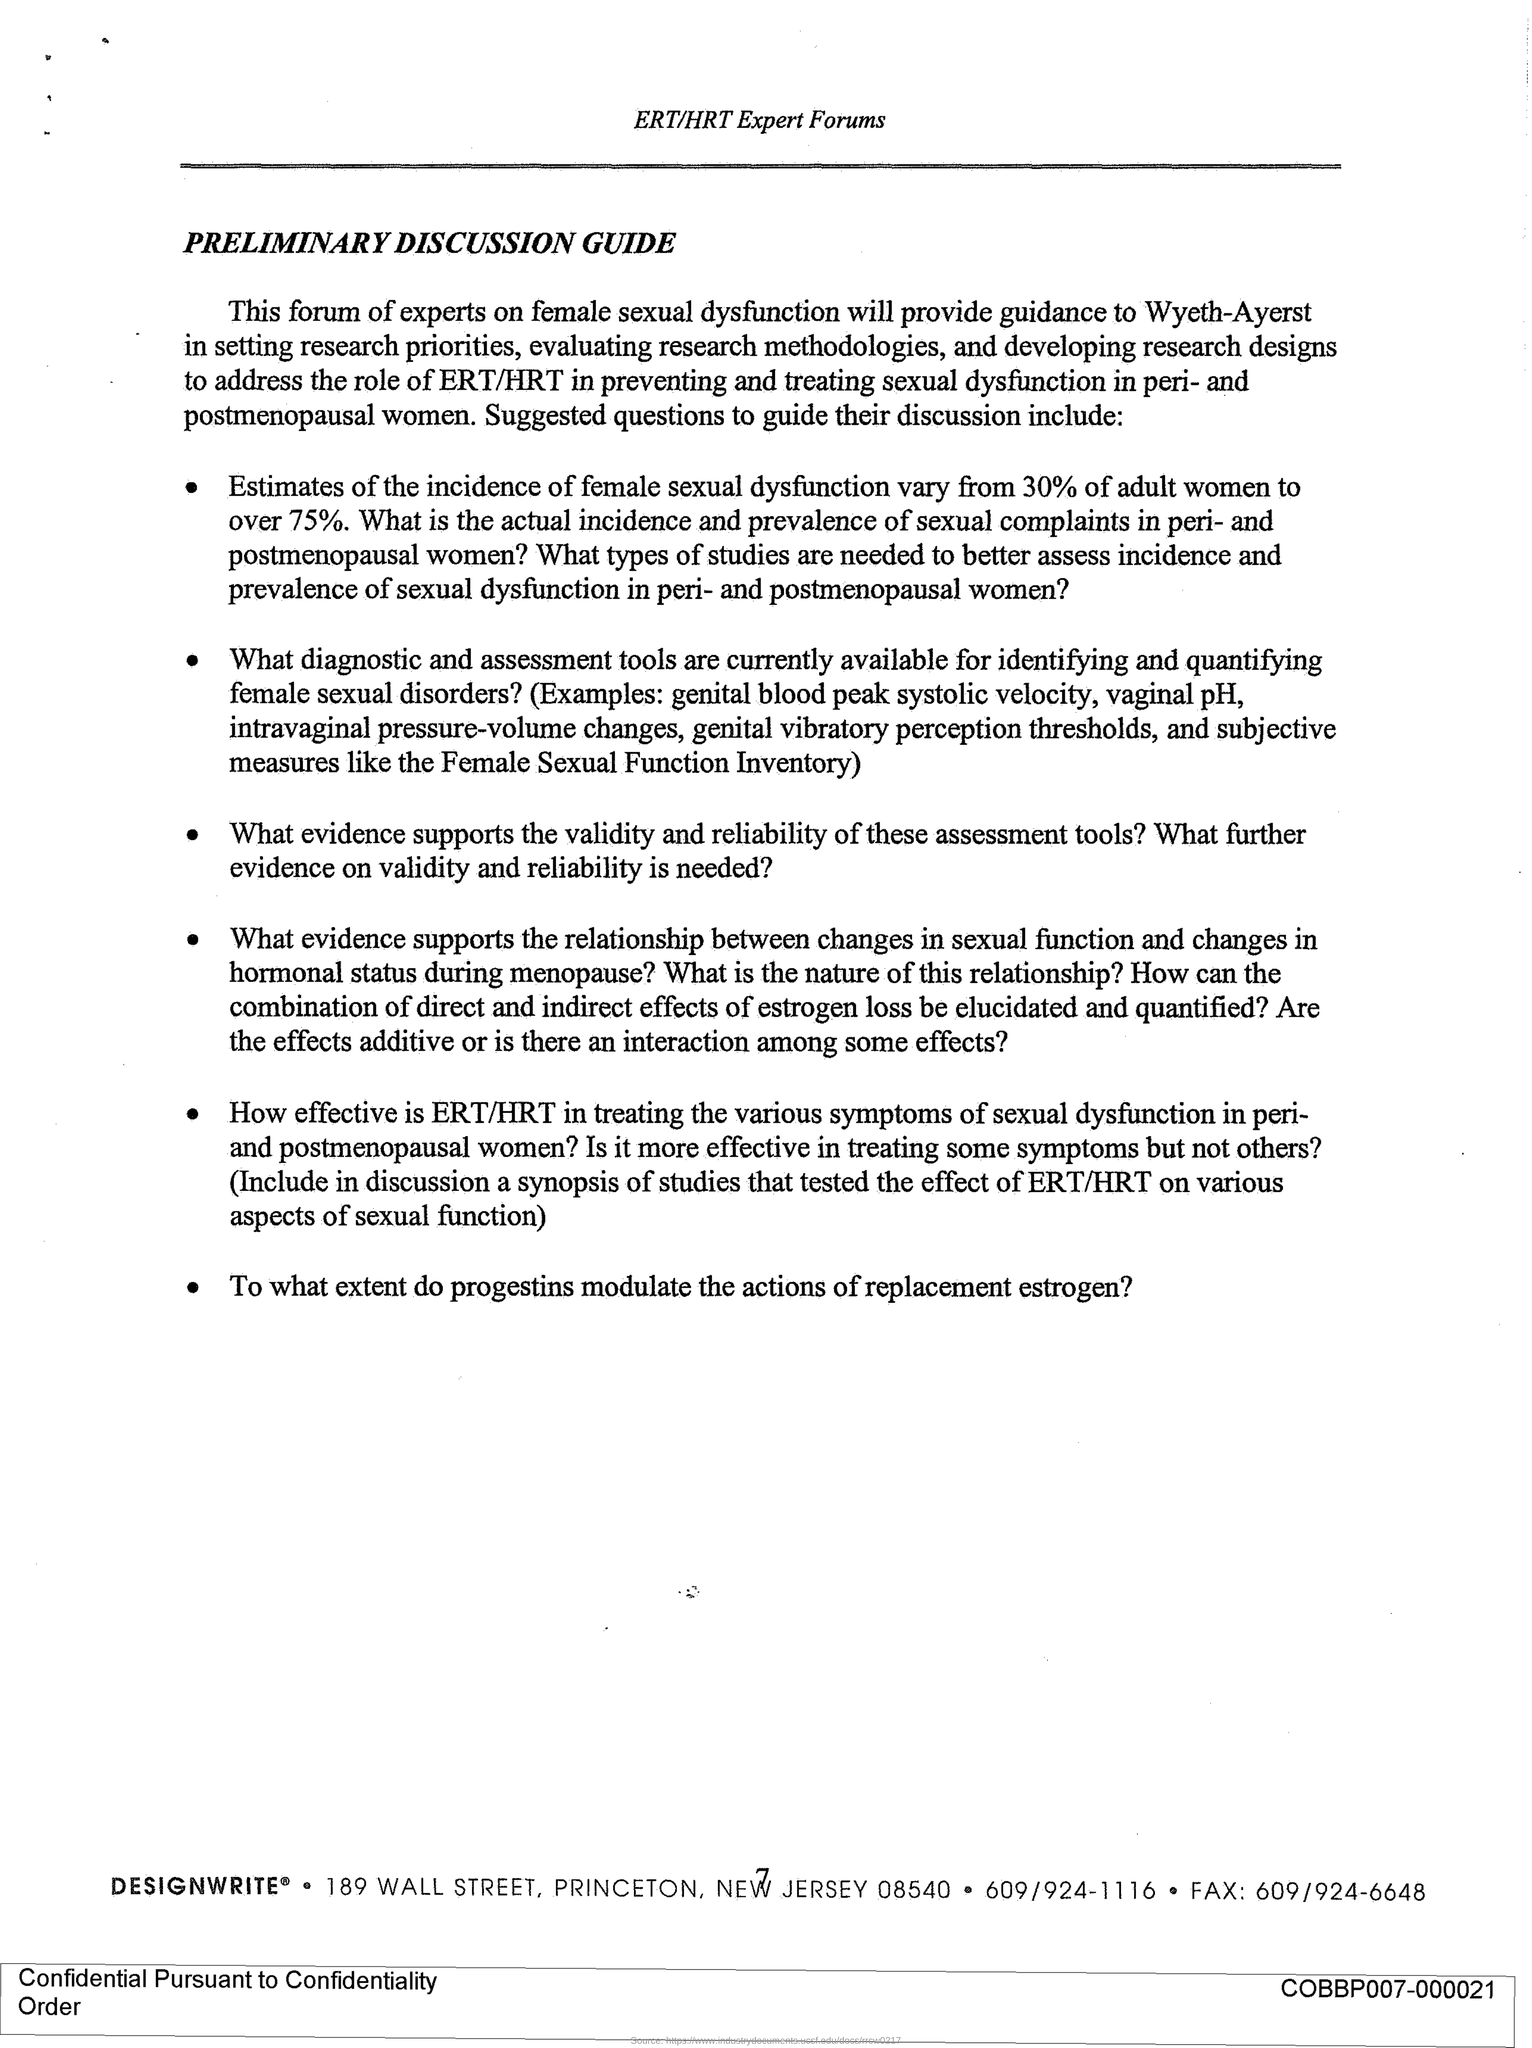List a handful of essential elements in this visual. The page number mentioned in this document is 7.. The title of this document is 'Preliminary Discussion Guide.' The ERT/HRT Expert Forums are mentioned in the header of the document. 